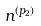<formula> <loc_0><loc_0><loc_500><loc_500>n ^ { ( p _ { 2 } ) }</formula> 